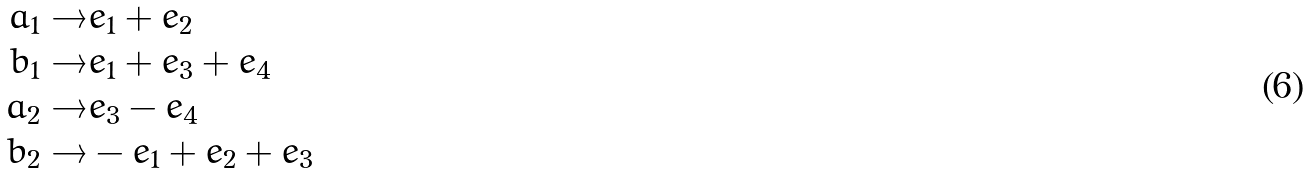<formula> <loc_0><loc_0><loc_500><loc_500>a _ { 1 } \to & e _ { 1 } + e _ { 2 } \\ b _ { 1 } \to & e _ { 1 } + e _ { 3 } + e _ { 4 } \\ a _ { 2 } \to & e _ { 3 } - e _ { 4 } \\ b _ { 2 } \to & - e _ { 1 } + e _ { 2 } + e _ { 3 } \\</formula> 